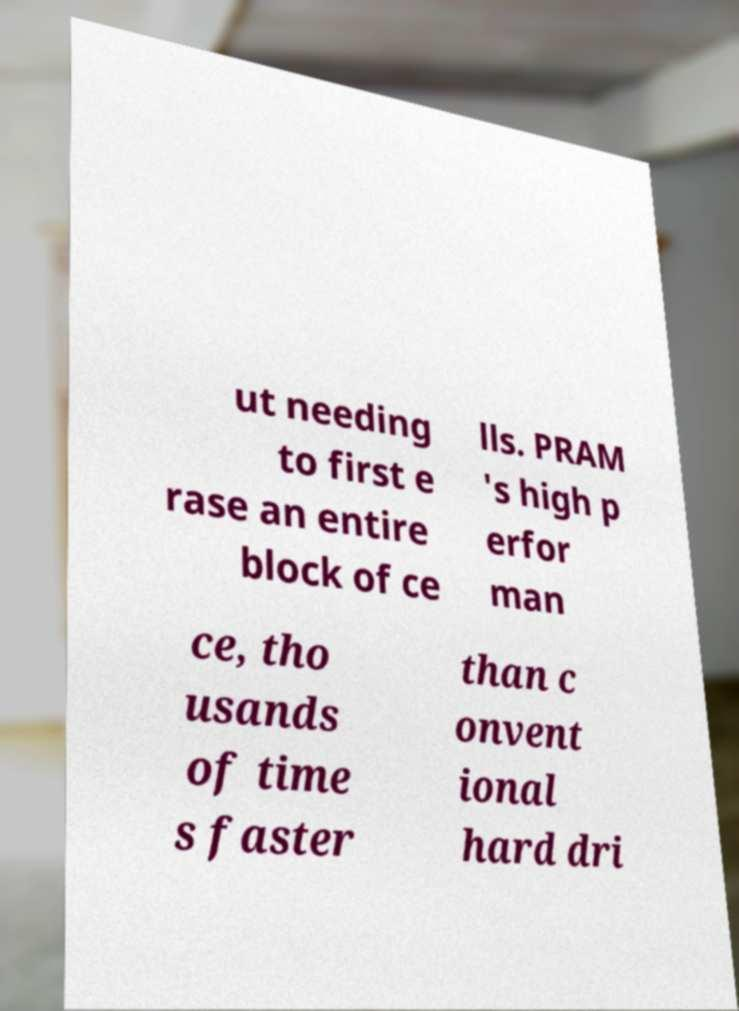Please read and relay the text visible in this image. What does it say? ut needing to first e rase an entire block of ce lls. PRAM 's high p erfor man ce, tho usands of time s faster than c onvent ional hard dri 